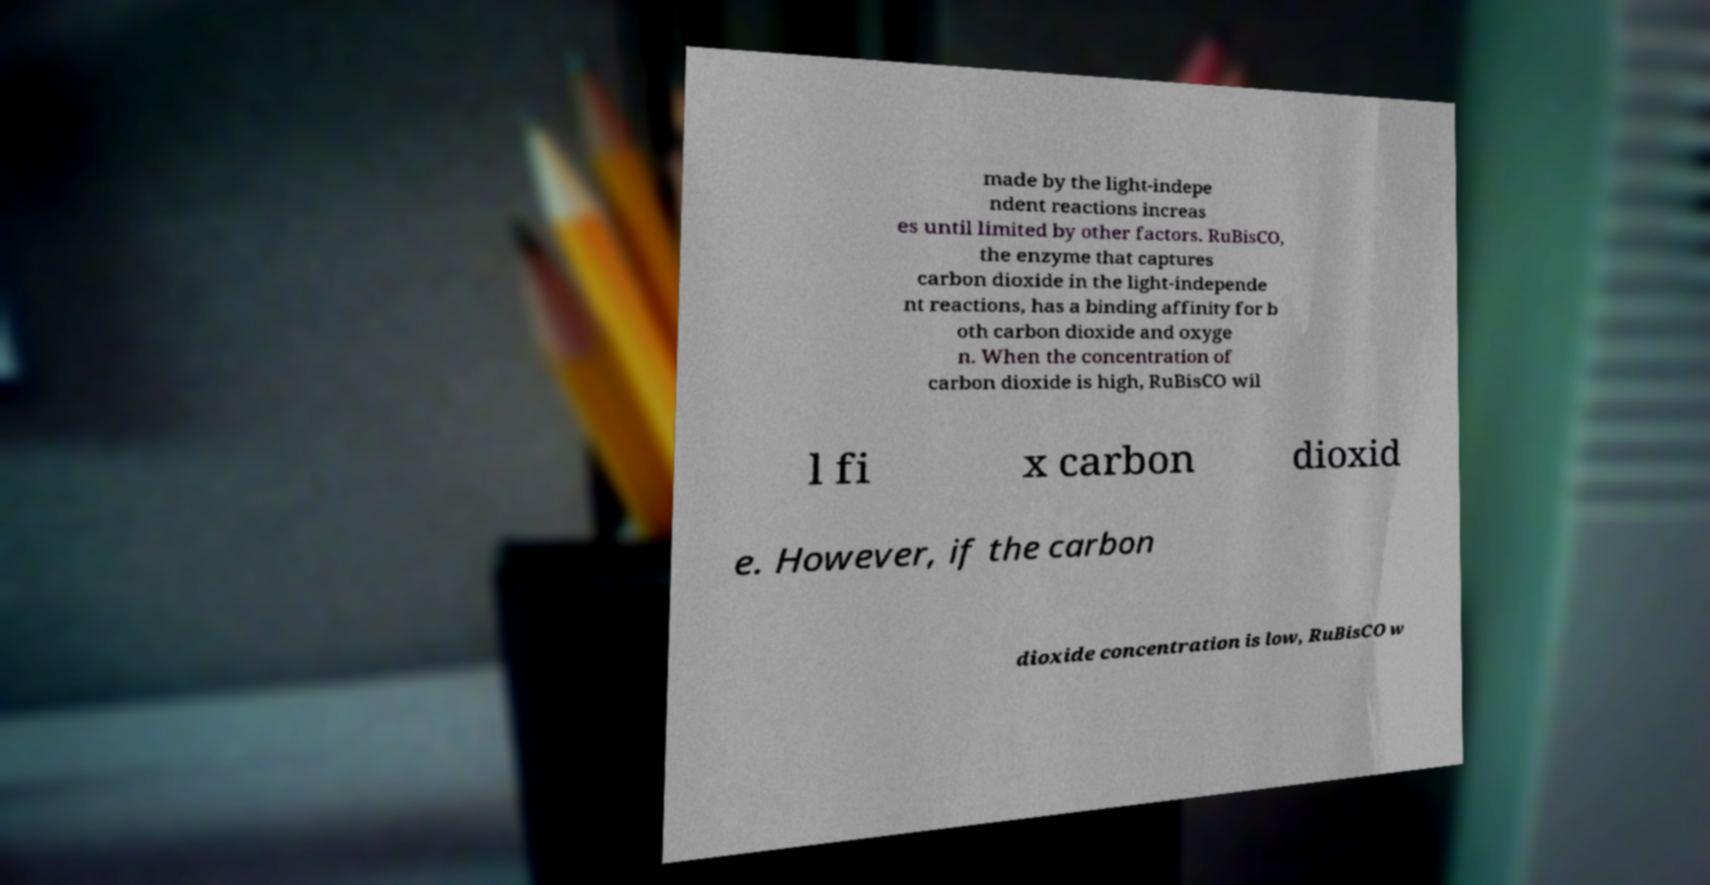Can you read and provide the text displayed in the image?This photo seems to have some interesting text. Can you extract and type it out for me? made by the light-indepe ndent reactions increas es until limited by other factors. RuBisCO, the enzyme that captures carbon dioxide in the light-independe nt reactions, has a binding affinity for b oth carbon dioxide and oxyge n. When the concentration of carbon dioxide is high, RuBisCO wil l fi x carbon dioxid e. However, if the carbon dioxide concentration is low, RuBisCO w 